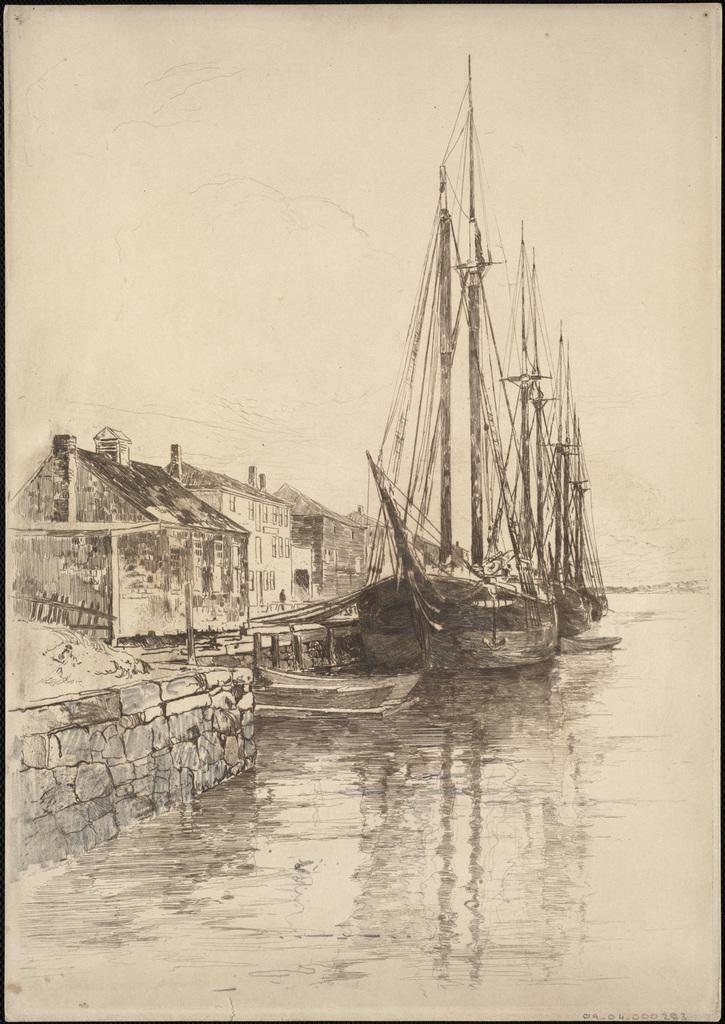What type of artwork is present in the image? The image contains a sketch. What is the main subject of the sketch? The sketch depicts a ship in the water. Are there any other elements in the sketch besides the ship? Yes, the sketch also includes houses and buildings. How many beggars can be seen in the sketch? There are no beggars depicted in the sketch; it features a ship, houses, and buildings. What type of mineral is present in the sketch? There is no mineral mentioned or depicted in the sketch; it is a drawing of a ship, houses, and buildings. 